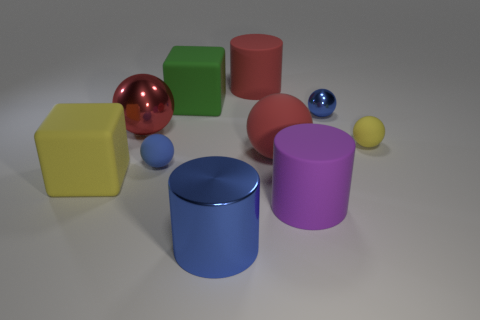Which objects in the image seem to have a textured surface? None of the objects in the image appear to have a textured surface; all of them seem to have smooth finishes. The green cube and the red ball might seem slightly less reflective than the others, but they don't have visible textures. 